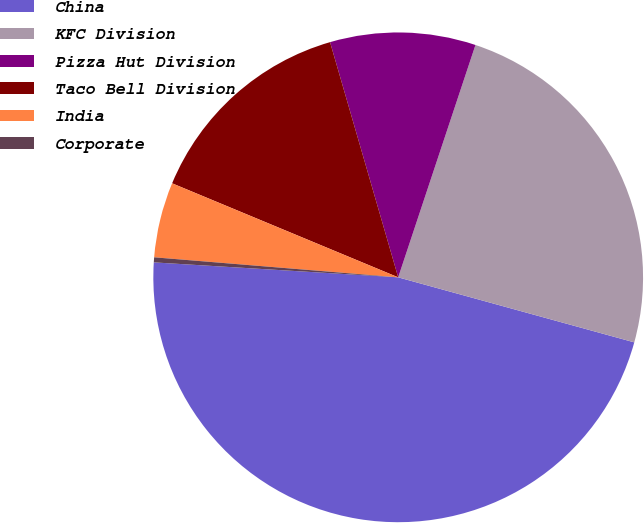<chart> <loc_0><loc_0><loc_500><loc_500><pie_chart><fcel>China<fcel>KFC Division<fcel>Pizza Hut Division<fcel>Taco Bell Division<fcel>India<fcel>Corporate<nl><fcel>46.7%<fcel>24.17%<fcel>9.6%<fcel>14.24%<fcel>4.97%<fcel>0.33%<nl></chart> 